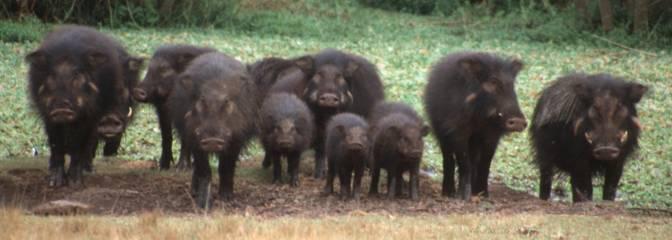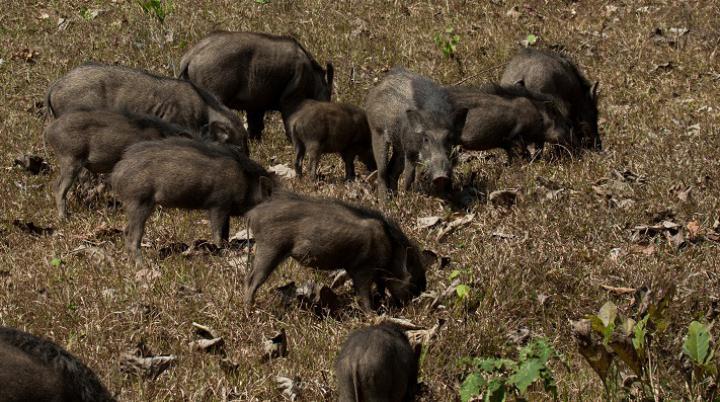The first image is the image on the left, the second image is the image on the right. Considering the images on both sides, is "In the image on the right all of the warthogs are walking to the left." valid? Answer yes or no. No. The first image is the image on the left, the second image is the image on the right. For the images shown, is this caption "the right image contains no more than five boars." true? Answer yes or no. No. 